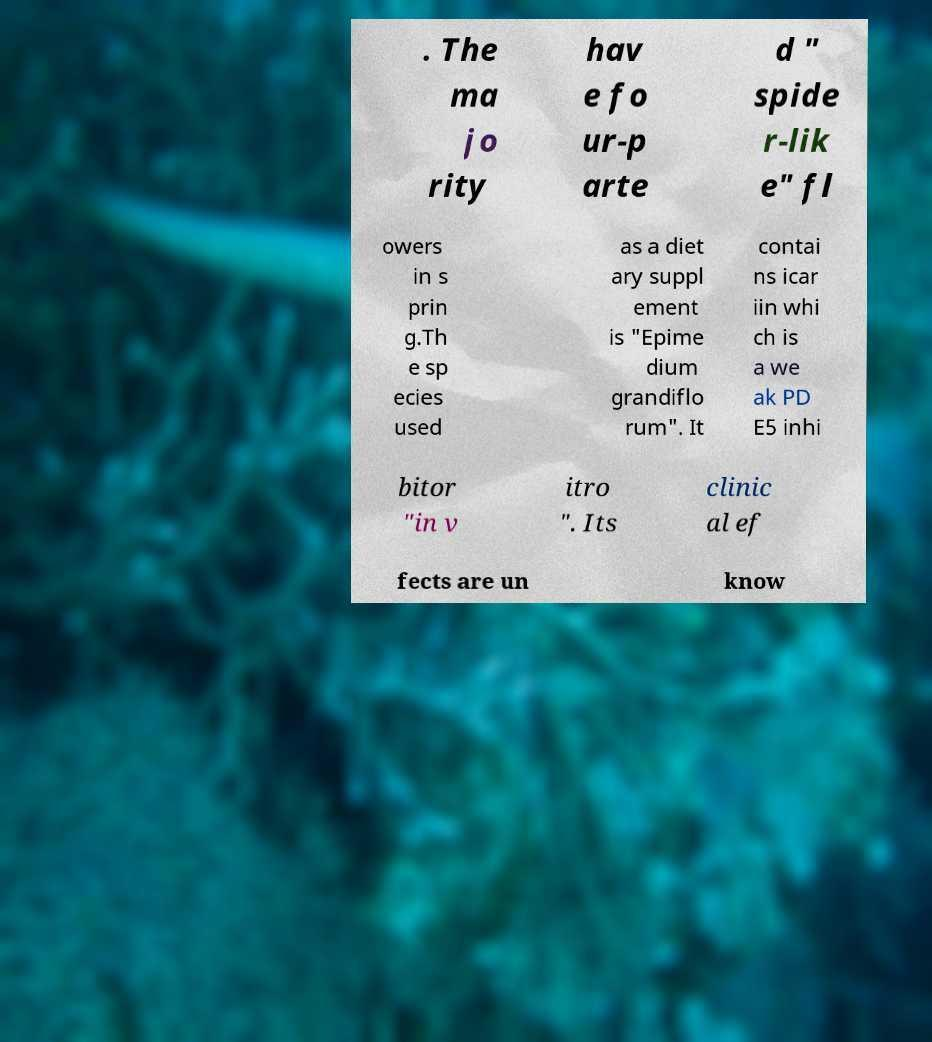Can you read and provide the text displayed in the image?This photo seems to have some interesting text. Can you extract and type it out for me? . The ma jo rity hav e fo ur-p arte d " spide r-lik e" fl owers in s prin g.Th e sp ecies used as a diet ary suppl ement is "Epime dium grandiflo rum". It contai ns icar iin whi ch is a we ak PD E5 inhi bitor "in v itro ". Its clinic al ef fects are un know 